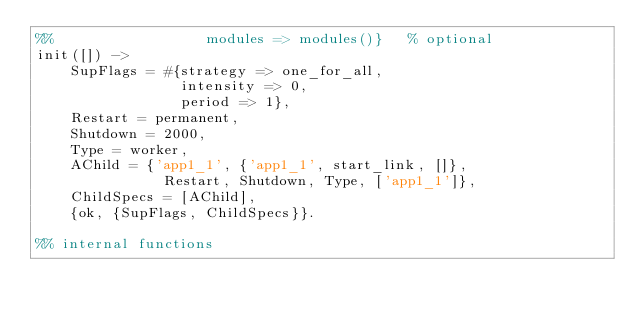Convert code to text. <code><loc_0><loc_0><loc_500><loc_500><_Erlang_>%%                  modules => modules()}   % optional
init([]) ->
    SupFlags = #{strategy => one_for_all,
                 intensity => 0,
                 period => 1},
    Restart = permanent,
    Shutdown = 2000,
    Type = worker,
    AChild = {'app1_1', {'app1_1', start_link, []},
               Restart, Shutdown, Type, ['app1_1']},
    ChildSpecs = [AChild],
    {ok, {SupFlags, ChildSpecs}}.

%% internal functions
</code> 